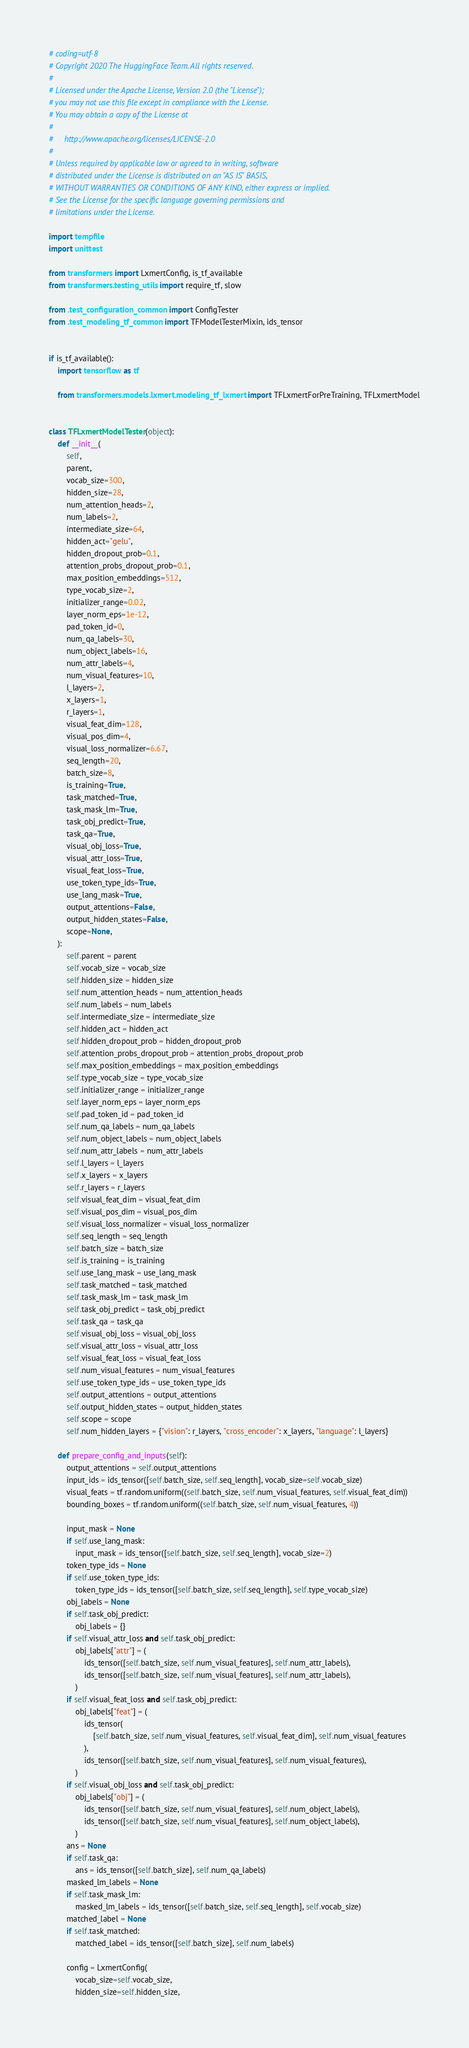<code> <loc_0><loc_0><loc_500><loc_500><_Python_># coding=utf-8
# Copyright 2020 The HuggingFace Team. All rights reserved.
#
# Licensed under the Apache License, Version 2.0 (the "License");
# you may not use this file except in compliance with the License.
# You may obtain a copy of the License at
#
#     http://www.apache.org/licenses/LICENSE-2.0
#
# Unless required by applicable law or agreed to in writing, software
# distributed under the License is distributed on an "AS IS" BASIS,
# WITHOUT WARRANTIES OR CONDITIONS OF ANY KIND, either express or implied.
# See the License for the specific language governing permissions and
# limitations under the License.

import tempfile
import unittest

from transformers import LxmertConfig, is_tf_available
from transformers.testing_utils import require_tf, slow

from .test_configuration_common import ConfigTester
from .test_modeling_tf_common import TFModelTesterMixin, ids_tensor


if is_tf_available():
    import tensorflow as tf

    from transformers.models.lxmert.modeling_tf_lxmert import TFLxmertForPreTraining, TFLxmertModel


class TFLxmertModelTester(object):
    def __init__(
        self,
        parent,
        vocab_size=300,
        hidden_size=28,
        num_attention_heads=2,
        num_labels=2,
        intermediate_size=64,
        hidden_act="gelu",
        hidden_dropout_prob=0.1,
        attention_probs_dropout_prob=0.1,
        max_position_embeddings=512,
        type_vocab_size=2,
        initializer_range=0.02,
        layer_norm_eps=1e-12,
        pad_token_id=0,
        num_qa_labels=30,
        num_object_labels=16,
        num_attr_labels=4,
        num_visual_features=10,
        l_layers=2,
        x_layers=1,
        r_layers=1,
        visual_feat_dim=128,
        visual_pos_dim=4,
        visual_loss_normalizer=6.67,
        seq_length=20,
        batch_size=8,
        is_training=True,
        task_matched=True,
        task_mask_lm=True,
        task_obj_predict=True,
        task_qa=True,
        visual_obj_loss=True,
        visual_attr_loss=True,
        visual_feat_loss=True,
        use_token_type_ids=True,
        use_lang_mask=True,
        output_attentions=False,
        output_hidden_states=False,
        scope=None,
    ):
        self.parent = parent
        self.vocab_size = vocab_size
        self.hidden_size = hidden_size
        self.num_attention_heads = num_attention_heads
        self.num_labels = num_labels
        self.intermediate_size = intermediate_size
        self.hidden_act = hidden_act
        self.hidden_dropout_prob = hidden_dropout_prob
        self.attention_probs_dropout_prob = attention_probs_dropout_prob
        self.max_position_embeddings = max_position_embeddings
        self.type_vocab_size = type_vocab_size
        self.initializer_range = initializer_range
        self.layer_norm_eps = layer_norm_eps
        self.pad_token_id = pad_token_id
        self.num_qa_labels = num_qa_labels
        self.num_object_labels = num_object_labels
        self.num_attr_labels = num_attr_labels
        self.l_layers = l_layers
        self.x_layers = x_layers
        self.r_layers = r_layers
        self.visual_feat_dim = visual_feat_dim
        self.visual_pos_dim = visual_pos_dim
        self.visual_loss_normalizer = visual_loss_normalizer
        self.seq_length = seq_length
        self.batch_size = batch_size
        self.is_training = is_training
        self.use_lang_mask = use_lang_mask
        self.task_matched = task_matched
        self.task_mask_lm = task_mask_lm
        self.task_obj_predict = task_obj_predict
        self.task_qa = task_qa
        self.visual_obj_loss = visual_obj_loss
        self.visual_attr_loss = visual_attr_loss
        self.visual_feat_loss = visual_feat_loss
        self.num_visual_features = num_visual_features
        self.use_token_type_ids = use_token_type_ids
        self.output_attentions = output_attentions
        self.output_hidden_states = output_hidden_states
        self.scope = scope
        self.num_hidden_layers = {"vision": r_layers, "cross_encoder": x_layers, "language": l_layers}

    def prepare_config_and_inputs(self):
        output_attentions = self.output_attentions
        input_ids = ids_tensor([self.batch_size, self.seq_length], vocab_size=self.vocab_size)
        visual_feats = tf.random.uniform((self.batch_size, self.num_visual_features, self.visual_feat_dim))
        bounding_boxes = tf.random.uniform((self.batch_size, self.num_visual_features, 4))

        input_mask = None
        if self.use_lang_mask:
            input_mask = ids_tensor([self.batch_size, self.seq_length], vocab_size=2)
        token_type_ids = None
        if self.use_token_type_ids:
            token_type_ids = ids_tensor([self.batch_size, self.seq_length], self.type_vocab_size)
        obj_labels = None
        if self.task_obj_predict:
            obj_labels = {}
        if self.visual_attr_loss and self.task_obj_predict:
            obj_labels["attr"] = (
                ids_tensor([self.batch_size, self.num_visual_features], self.num_attr_labels),
                ids_tensor([self.batch_size, self.num_visual_features], self.num_attr_labels),
            )
        if self.visual_feat_loss and self.task_obj_predict:
            obj_labels["feat"] = (
                ids_tensor(
                    [self.batch_size, self.num_visual_features, self.visual_feat_dim], self.num_visual_features
                ),
                ids_tensor([self.batch_size, self.num_visual_features], self.num_visual_features),
            )
        if self.visual_obj_loss and self.task_obj_predict:
            obj_labels["obj"] = (
                ids_tensor([self.batch_size, self.num_visual_features], self.num_object_labels),
                ids_tensor([self.batch_size, self.num_visual_features], self.num_object_labels),
            )
        ans = None
        if self.task_qa:
            ans = ids_tensor([self.batch_size], self.num_qa_labels)
        masked_lm_labels = None
        if self.task_mask_lm:
            masked_lm_labels = ids_tensor([self.batch_size, self.seq_length], self.vocab_size)
        matched_label = None
        if self.task_matched:
            matched_label = ids_tensor([self.batch_size], self.num_labels)

        config = LxmertConfig(
            vocab_size=self.vocab_size,
            hidden_size=self.hidden_size,</code> 